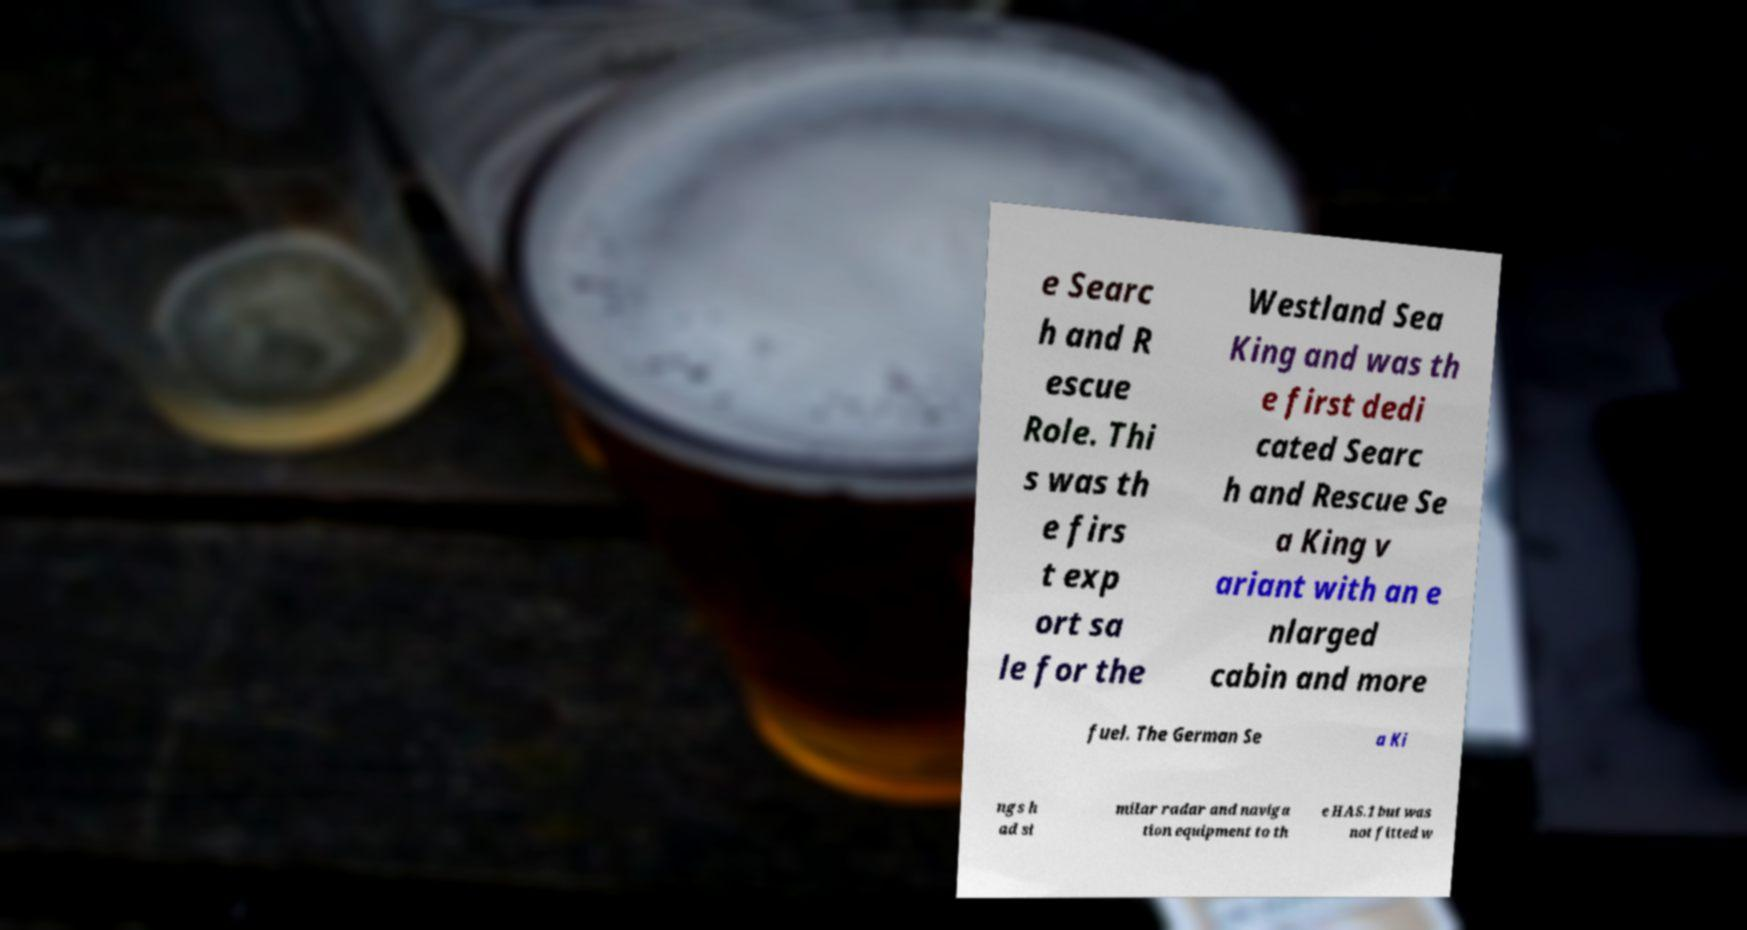Can you accurately transcribe the text from the provided image for me? e Searc h and R escue Role. Thi s was th e firs t exp ort sa le for the Westland Sea King and was th e first dedi cated Searc h and Rescue Se a King v ariant with an e nlarged cabin and more fuel. The German Se a Ki ngs h ad si milar radar and naviga tion equipment to th e HAS.1 but was not fitted w 